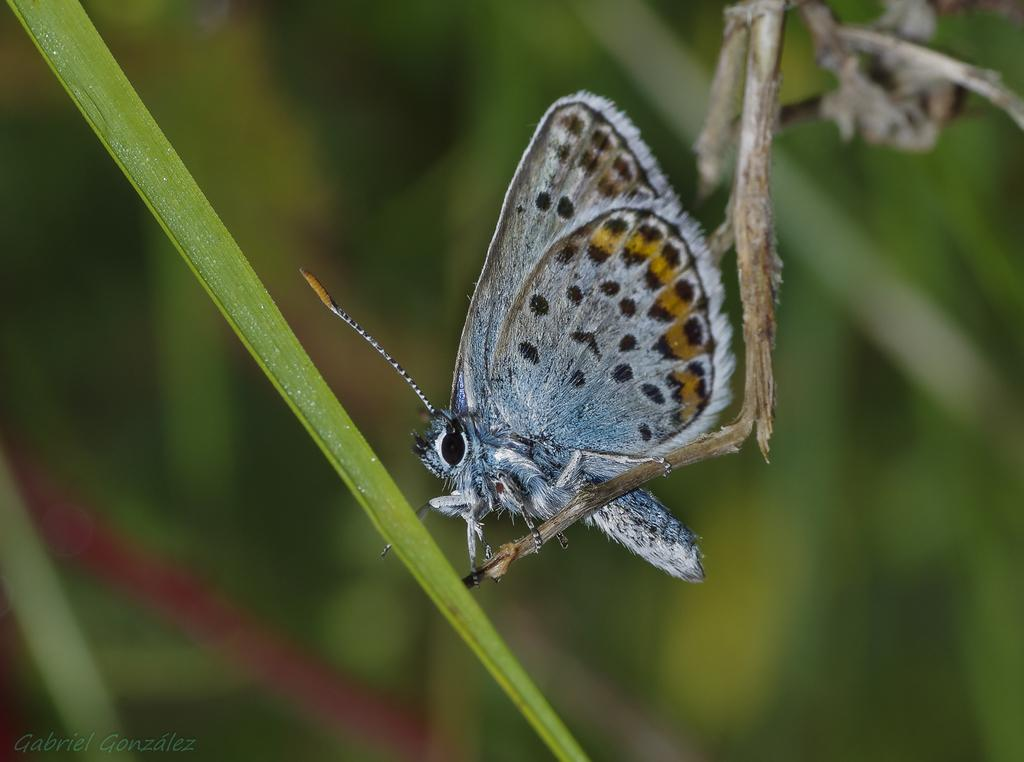What is: What type of insect can be seen in the picture? There is a butterfly in the picture. What other elements are present in the picture besides the butterfly? Leaves and a stem are present in the picture. What colors are the butterfly, leaves, and stem in the picture? They have colors: black, white, and yellow. What type of soda is being poured into the glass in the picture? There is: There is no soda or glass present in the picture; it features a butterfly, leaves, and a stem with black, white, and yellow colors. 